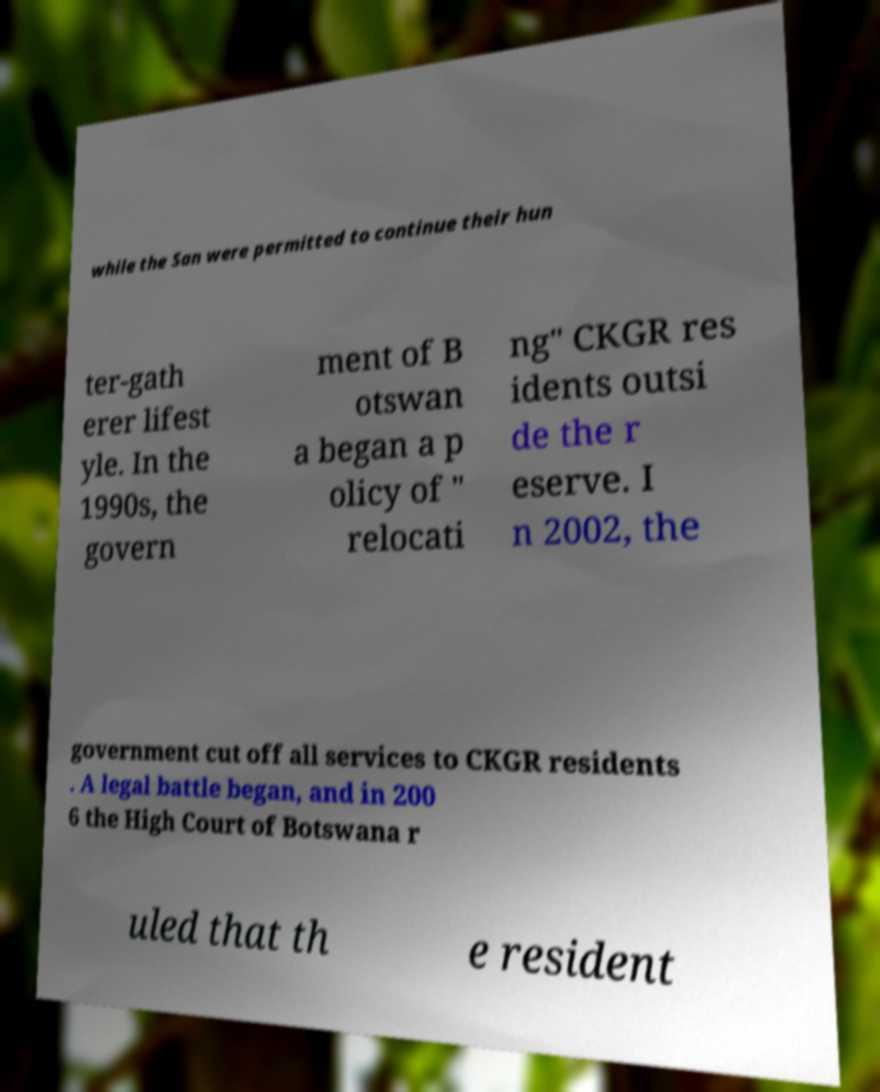Can you read and provide the text displayed in the image?This photo seems to have some interesting text. Can you extract and type it out for me? while the San were permitted to continue their hun ter-gath erer lifest yle. In the 1990s, the govern ment of B otswan a began a p olicy of " relocati ng" CKGR res idents outsi de the r eserve. I n 2002, the government cut off all services to CKGR residents . A legal battle began, and in 200 6 the High Court of Botswana r uled that th e resident 